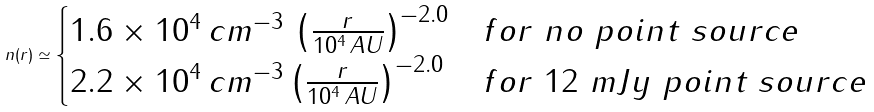Convert formula to latex. <formula><loc_0><loc_0><loc_500><loc_500>n ( r ) \simeq \begin{cases} 1 . 6 \times 1 0 ^ { 4 } \, c m ^ { - 3 } \, \left ( \frac { r } { 1 0 ^ { 4 } \, A U } \right ) ^ { - 2 . 0 } & f o r \ n o \ p o i n t \ s o u r c e \\ 2 . 2 \times 1 0 ^ { 4 } \, c m ^ { - 3 } \left ( \frac { r } { 1 0 ^ { 4 } \, A U } \right ) ^ { - 2 . 0 } & f o r \ 1 2 \ m J y \ p o i n t \ s o u r c e \end{cases}</formula> 